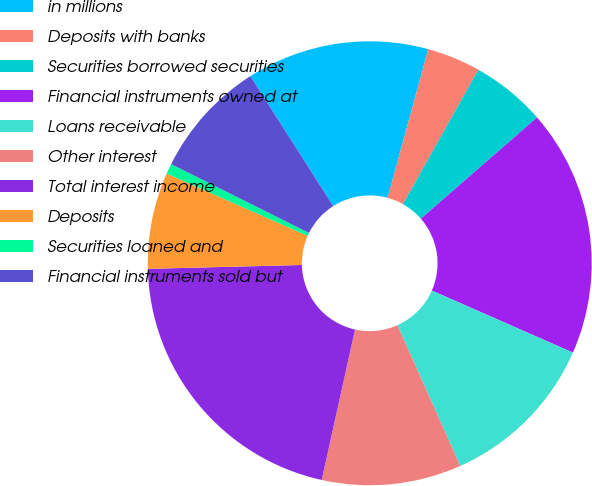<chart> <loc_0><loc_0><loc_500><loc_500><pie_chart><fcel>in millions<fcel>Deposits with banks<fcel>Securities borrowed securities<fcel>Financial instruments owned at<fcel>Loans receivable<fcel>Other interest<fcel>Total interest income<fcel>Deposits<fcel>Securities loaned and<fcel>Financial instruments sold but<nl><fcel>13.29%<fcel>3.89%<fcel>5.45%<fcel>18.0%<fcel>11.72%<fcel>10.16%<fcel>21.13%<fcel>7.02%<fcel>0.75%<fcel>8.59%<nl></chart> 